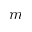Convert formula to latex. <formula><loc_0><loc_0><loc_500><loc_500>m</formula> 